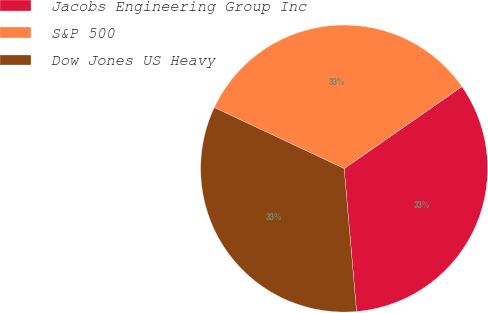<chart> <loc_0><loc_0><loc_500><loc_500><pie_chart><fcel>Jacobs Engineering Group Inc<fcel>S&P 500<fcel>Dow Jones US Heavy<nl><fcel>33.3%<fcel>33.33%<fcel>33.37%<nl></chart> 